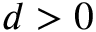<formula> <loc_0><loc_0><loc_500><loc_500>d > 0</formula> 